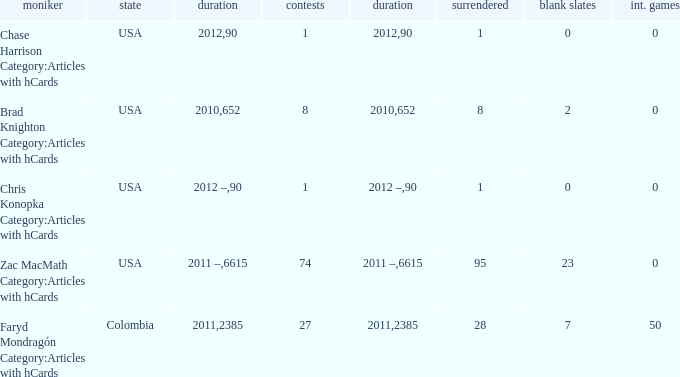When chase harrison category:articles with hcards is the name what is the year? 2012.0. 